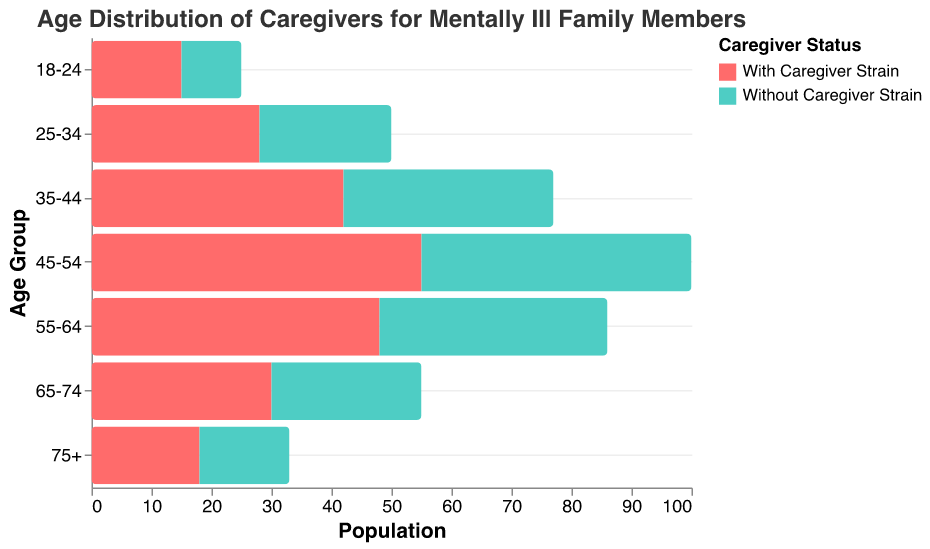What is the title of the figure? The title of the figure is displayed at the top. It reads "Age Distribution of Caregivers for Mentally Ill Family Members".
Answer: Age Distribution of Caregivers for Mentally Ill Family Members How many age groups are shown in the figure? The age groups are labeled on the y-axis and include 18-24, 25-34, 35-44, 45-54, 55-64, 65-74, and 75+. Counting these, there are 7 age groups shown.
Answer: 7 Which age group has the highest population of caregivers without caregiver strain? By looking at the bars on the right side (Without Caregiver Strain), the highest value is for the age group 45-54 with a value of 45.
Answer: 45-54 What is the difference in the number of caregivers with strain and without strain in the 35-44 age group? The population for 35-44 with caregiver strain is -42, and without strain is 35. The difference is 42 + 35 = 77.
Answer: 77 In which age group is the difference between caregivers with strain and without strain the smallest? To find the smallest difference, we evaluate all the age groups and note the differences: 18-24 (25), 25-34 (50), 35-44 (77), 45-54 (100), 55-64 (86), 65-74 (55), 75+ (33). The smallest difference is in the 18-24 age group with a difference of 25.
Answer: 18-24 Which age group has the smallest population of caregivers with strain? The bars on the left side (With Caregiver Strain) show the smallest value is for the age group 18-24 with a value of -15.
Answer: 18-24 Is the number of caregivers without strain greater than caregivers with strain in every age group? Checking each age group, in every instance, the absolute value of the population for caregivers without strain is greater than that for those with strain, so this statement is true.
Answer: Yes What is the sum of caregivers with strain across all age groups? Summing up the absolute values for all age groups with strain: 15 + 28 + 42 + 55 + 48 + 30 + 18 = 236.
Answer: 236 